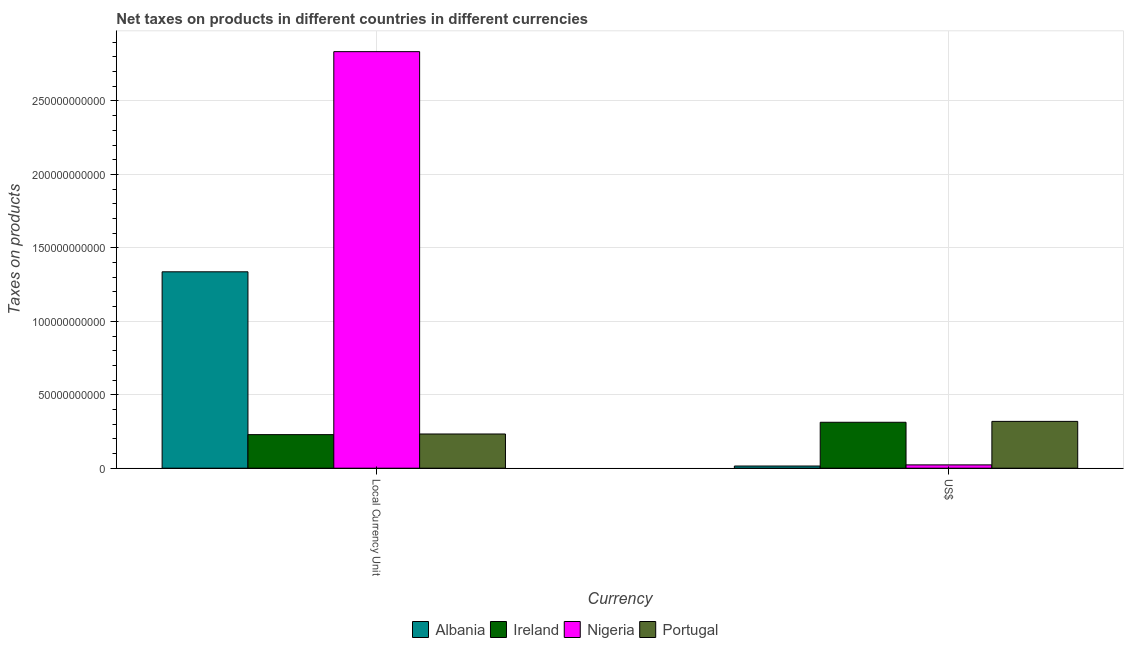How many different coloured bars are there?
Keep it short and to the point. 4. Are the number of bars per tick equal to the number of legend labels?
Your response must be concise. Yes. What is the label of the 1st group of bars from the left?
Offer a very short reply. Local Currency Unit. What is the net taxes in constant 2005 us$ in Ireland?
Give a very brief answer. 2.28e+1. Across all countries, what is the maximum net taxes in constant 2005 us$?
Make the answer very short. 2.84e+11. Across all countries, what is the minimum net taxes in constant 2005 us$?
Keep it short and to the point. 2.28e+1. In which country was the net taxes in constant 2005 us$ maximum?
Ensure brevity in your answer.  Nigeria. In which country was the net taxes in us$ minimum?
Your answer should be very brief. Albania. What is the total net taxes in us$ in the graph?
Make the answer very short. 6.69e+1. What is the difference between the net taxes in us$ in Albania and that in Portugal?
Offer a very short reply. -3.04e+1. What is the difference between the net taxes in constant 2005 us$ in Nigeria and the net taxes in us$ in Albania?
Your answer should be very brief. 2.82e+11. What is the average net taxes in us$ per country?
Your answer should be very brief. 1.67e+1. What is the difference between the net taxes in constant 2005 us$ and net taxes in us$ in Portugal?
Offer a terse response. -8.59e+09. In how many countries, is the net taxes in constant 2005 us$ greater than 20000000000 units?
Ensure brevity in your answer.  4. What is the ratio of the net taxes in us$ in Portugal to that in Ireland?
Offer a terse response. 1.02. In how many countries, is the net taxes in constant 2005 us$ greater than the average net taxes in constant 2005 us$ taken over all countries?
Offer a terse response. 2. What does the 3rd bar from the right in Local Currency Unit represents?
Offer a terse response. Ireland. How many bars are there?
Offer a terse response. 8. Are all the bars in the graph horizontal?
Make the answer very short. No. Are the values on the major ticks of Y-axis written in scientific E-notation?
Keep it short and to the point. No. What is the title of the graph?
Keep it short and to the point. Net taxes on products in different countries in different currencies. What is the label or title of the X-axis?
Your answer should be compact. Currency. What is the label or title of the Y-axis?
Make the answer very short. Taxes on products. What is the Taxes on products of Albania in Local Currency Unit?
Provide a succinct answer. 1.34e+11. What is the Taxes on products of Ireland in Local Currency Unit?
Your answer should be very brief. 2.28e+1. What is the Taxes on products of Nigeria in Local Currency Unit?
Your response must be concise. 2.84e+11. What is the Taxes on products in Portugal in Local Currency Unit?
Offer a terse response. 2.33e+1. What is the Taxes on products in Albania in US$?
Keep it short and to the point. 1.48e+09. What is the Taxes on products of Ireland in US$?
Keep it short and to the point. 3.13e+1. What is the Taxes on products in Nigeria in US$?
Provide a succinct answer. 2.25e+09. What is the Taxes on products of Portugal in US$?
Provide a succinct answer. 3.19e+1. Across all Currency, what is the maximum Taxes on products in Albania?
Offer a very short reply. 1.34e+11. Across all Currency, what is the maximum Taxes on products in Ireland?
Offer a terse response. 3.13e+1. Across all Currency, what is the maximum Taxes on products of Nigeria?
Your answer should be very brief. 2.84e+11. Across all Currency, what is the maximum Taxes on products in Portugal?
Offer a very short reply. 3.19e+1. Across all Currency, what is the minimum Taxes on products in Albania?
Offer a terse response. 1.48e+09. Across all Currency, what is the minimum Taxes on products of Ireland?
Keep it short and to the point. 2.28e+1. Across all Currency, what is the minimum Taxes on products of Nigeria?
Your answer should be very brief. 2.25e+09. Across all Currency, what is the minimum Taxes on products in Portugal?
Your answer should be very brief. 2.33e+1. What is the total Taxes on products in Albania in the graph?
Provide a succinct answer. 1.35e+11. What is the total Taxes on products in Ireland in the graph?
Your answer should be compact. 5.41e+1. What is the total Taxes on products in Nigeria in the graph?
Your response must be concise. 2.86e+11. What is the total Taxes on products of Portugal in the graph?
Offer a terse response. 5.52e+1. What is the difference between the Taxes on products in Albania in Local Currency Unit and that in US$?
Provide a short and direct response. 1.32e+11. What is the difference between the Taxes on products in Ireland in Local Currency Unit and that in US$?
Your answer should be very brief. -8.42e+09. What is the difference between the Taxes on products in Nigeria in Local Currency Unit and that in US$?
Ensure brevity in your answer.  2.81e+11. What is the difference between the Taxes on products of Portugal in Local Currency Unit and that in US$?
Provide a short and direct response. -8.59e+09. What is the difference between the Taxes on products of Albania in Local Currency Unit and the Taxes on products of Ireland in US$?
Your response must be concise. 1.02e+11. What is the difference between the Taxes on products of Albania in Local Currency Unit and the Taxes on products of Nigeria in US$?
Offer a very short reply. 1.31e+11. What is the difference between the Taxes on products in Albania in Local Currency Unit and the Taxes on products in Portugal in US$?
Ensure brevity in your answer.  1.02e+11. What is the difference between the Taxes on products of Ireland in Local Currency Unit and the Taxes on products of Nigeria in US$?
Keep it short and to the point. 2.06e+1. What is the difference between the Taxes on products in Ireland in Local Currency Unit and the Taxes on products in Portugal in US$?
Provide a succinct answer. -9.03e+09. What is the difference between the Taxes on products in Nigeria in Local Currency Unit and the Taxes on products in Portugal in US$?
Your response must be concise. 2.52e+11. What is the average Taxes on products of Albania per Currency?
Provide a short and direct response. 6.76e+1. What is the average Taxes on products in Ireland per Currency?
Provide a succinct answer. 2.71e+1. What is the average Taxes on products in Nigeria per Currency?
Your response must be concise. 1.43e+11. What is the average Taxes on products of Portugal per Currency?
Keep it short and to the point. 2.76e+1. What is the difference between the Taxes on products of Albania and Taxes on products of Ireland in Local Currency Unit?
Your answer should be compact. 1.11e+11. What is the difference between the Taxes on products in Albania and Taxes on products in Nigeria in Local Currency Unit?
Offer a very short reply. -1.50e+11. What is the difference between the Taxes on products in Albania and Taxes on products in Portugal in Local Currency Unit?
Ensure brevity in your answer.  1.10e+11. What is the difference between the Taxes on products in Ireland and Taxes on products in Nigeria in Local Currency Unit?
Your response must be concise. -2.61e+11. What is the difference between the Taxes on products of Ireland and Taxes on products of Portugal in Local Currency Unit?
Provide a short and direct response. -4.40e+08. What is the difference between the Taxes on products in Nigeria and Taxes on products in Portugal in Local Currency Unit?
Ensure brevity in your answer.  2.60e+11. What is the difference between the Taxes on products in Albania and Taxes on products in Ireland in US$?
Make the answer very short. -2.98e+1. What is the difference between the Taxes on products in Albania and Taxes on products in Nigeria in US$?
Provide a succinct answer. -7.76e+08. What is the difference between the Taxes on products in Albania and Taxes on products in Portugal in US$?
Ensure brevity in your answer.  -3.04e+1. What is the difference between the Taxes on products in Ireland and Taxes on products in Nigeria in US$?
Give a very brief answer. 2.90e+1. What is the difference between the Taxes on products of Ireland and Taxes on products of Portugal in US$?
Your answer should be compact. -6.02e+08. What is the difference between the Taxes on products in Nigeria and Taxes on products in Portugal in US$?
Your response must be concise. -2.96e+1. What is the ratio of the Taxes on products in Albania in Local Currency Unit to that in US$?
Ensure brevity in your answer.  90.43. What is the ratio of the Taxes on products in Ireland in Local Currency Unit to that in US$?
Offer a very short reply. 0.73. What is the ratio of the Taxes on products of Nigeria in Local Currency Unit to that in US$?
Give a very brief answer. 125.81. What is the ratio of the Taxes on products of Portugal in Local Currency Unit to that in US$?
Your response must be concise. 0.73. What is the difference between the highest and the second highest Taxes on products in Albania?
Give a very brief answer. 1.32e+11. What is the difference between the highest and the second highest Taxes on products of Ireland?
Ensure brevity in your answer.  8.42e+09. What is the difference between the highest and the second highest Taxes on products of Nigeria?
Offer a very short reply. 2.81e+11. What is the difference between the highest and the second highest Taxes on products in Portugal?
Offer a terse response. 8.59e+09. What is the difference between the highest and the lowest Taxes on products of Albania?
Offer a terse response. 1.32e+11. What is the difference between the highest and the lowest Taxes on products in Ireland?
Your answer should be very brief. 8.42e+09. What is the difference between the highest and the lowest Taxes on products in Nigeria?
Give a very brief answer. 2.81e+11. What is the difference between the highest and the lowest Taxes on products of Portugal?
Provide a succinct answer. 8.59e+09. 